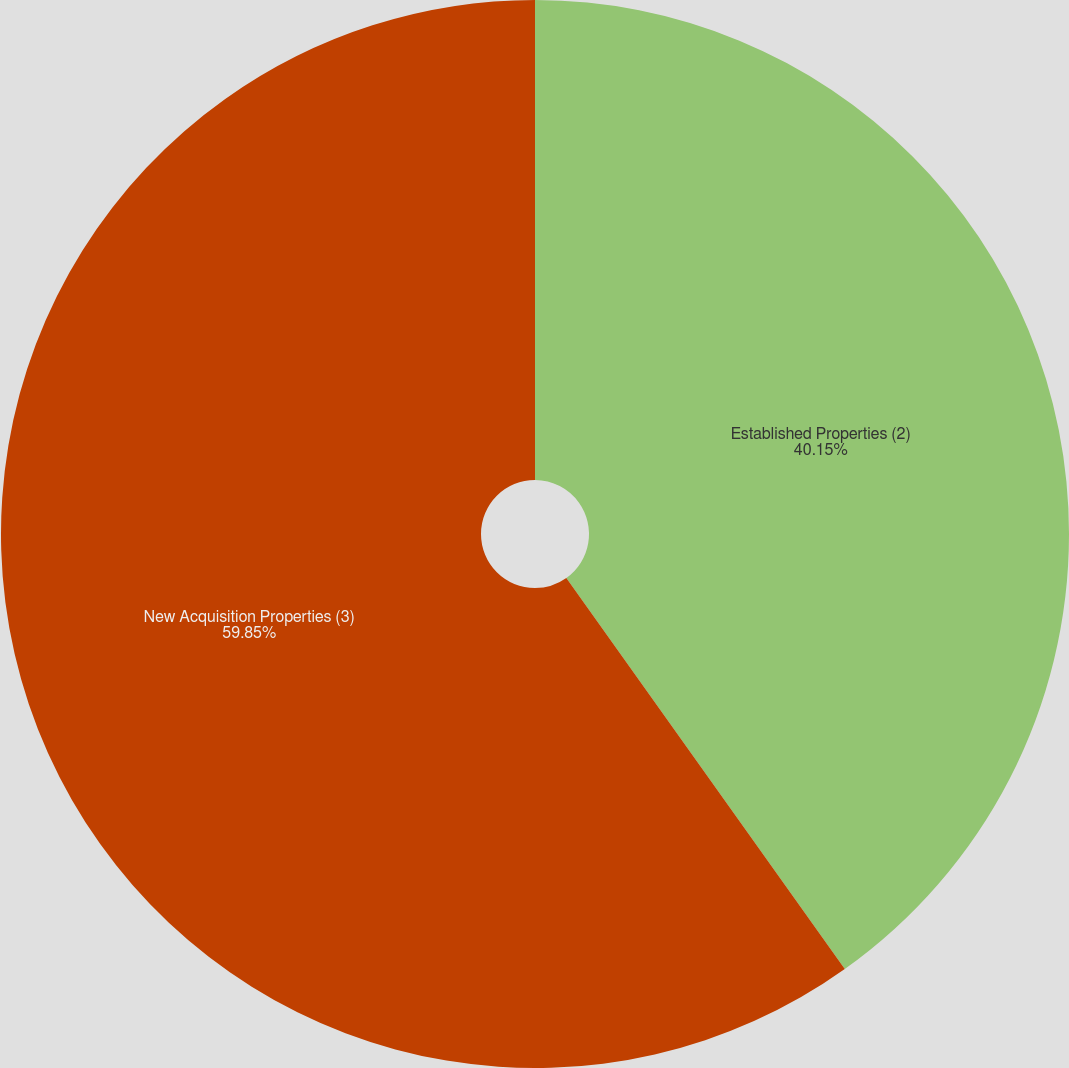<chart> <loc_0><loc_0><loc_500><loc_500><pie_chart><fcel>Established Properties (2)<fcel>New Acquisition Properties (3)<nl><fcel>40.15%<fcel>59.85%<nl></chart> 